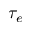Convert formula to latex. <formula><loc_0><loc_0><loc_500><loc_500>\tau _ { e }</formula> 